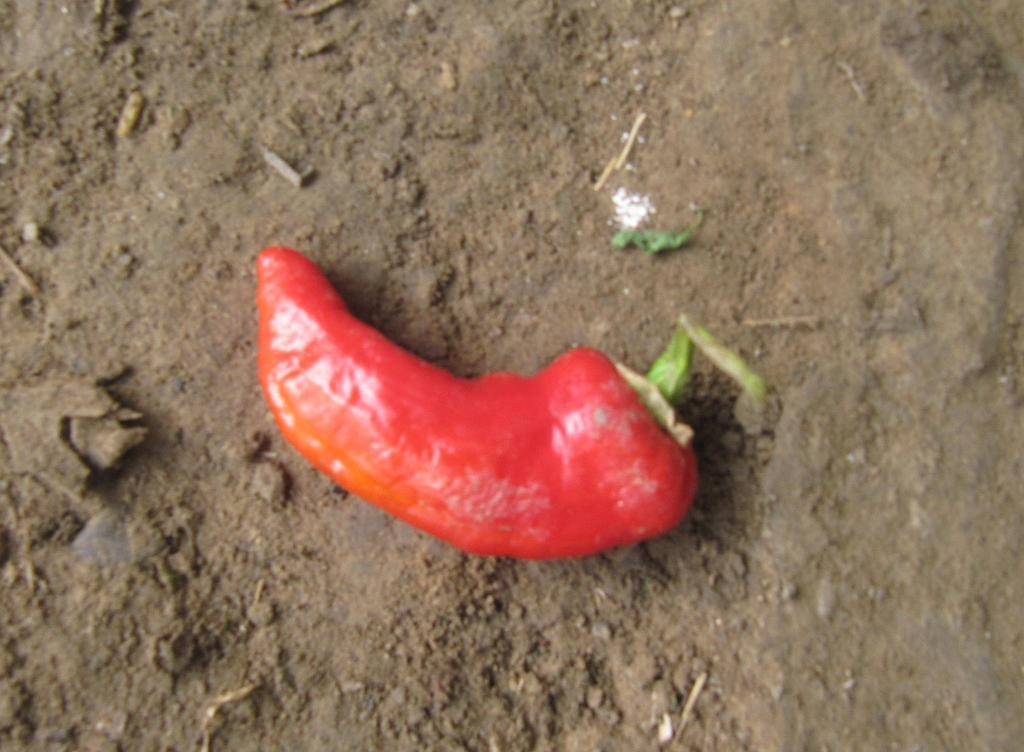What is the main subject of the image? The main subject of the image is a red chili. Where is the chili located in the image? The chili is on the ground in the image. What color is the background of the image? The background of the image is brown in color. What type of straw is being used to make a wish in the image? There is no straw or wish-making activity present in the image. The image only features a red chili on the ground with a brown background. 